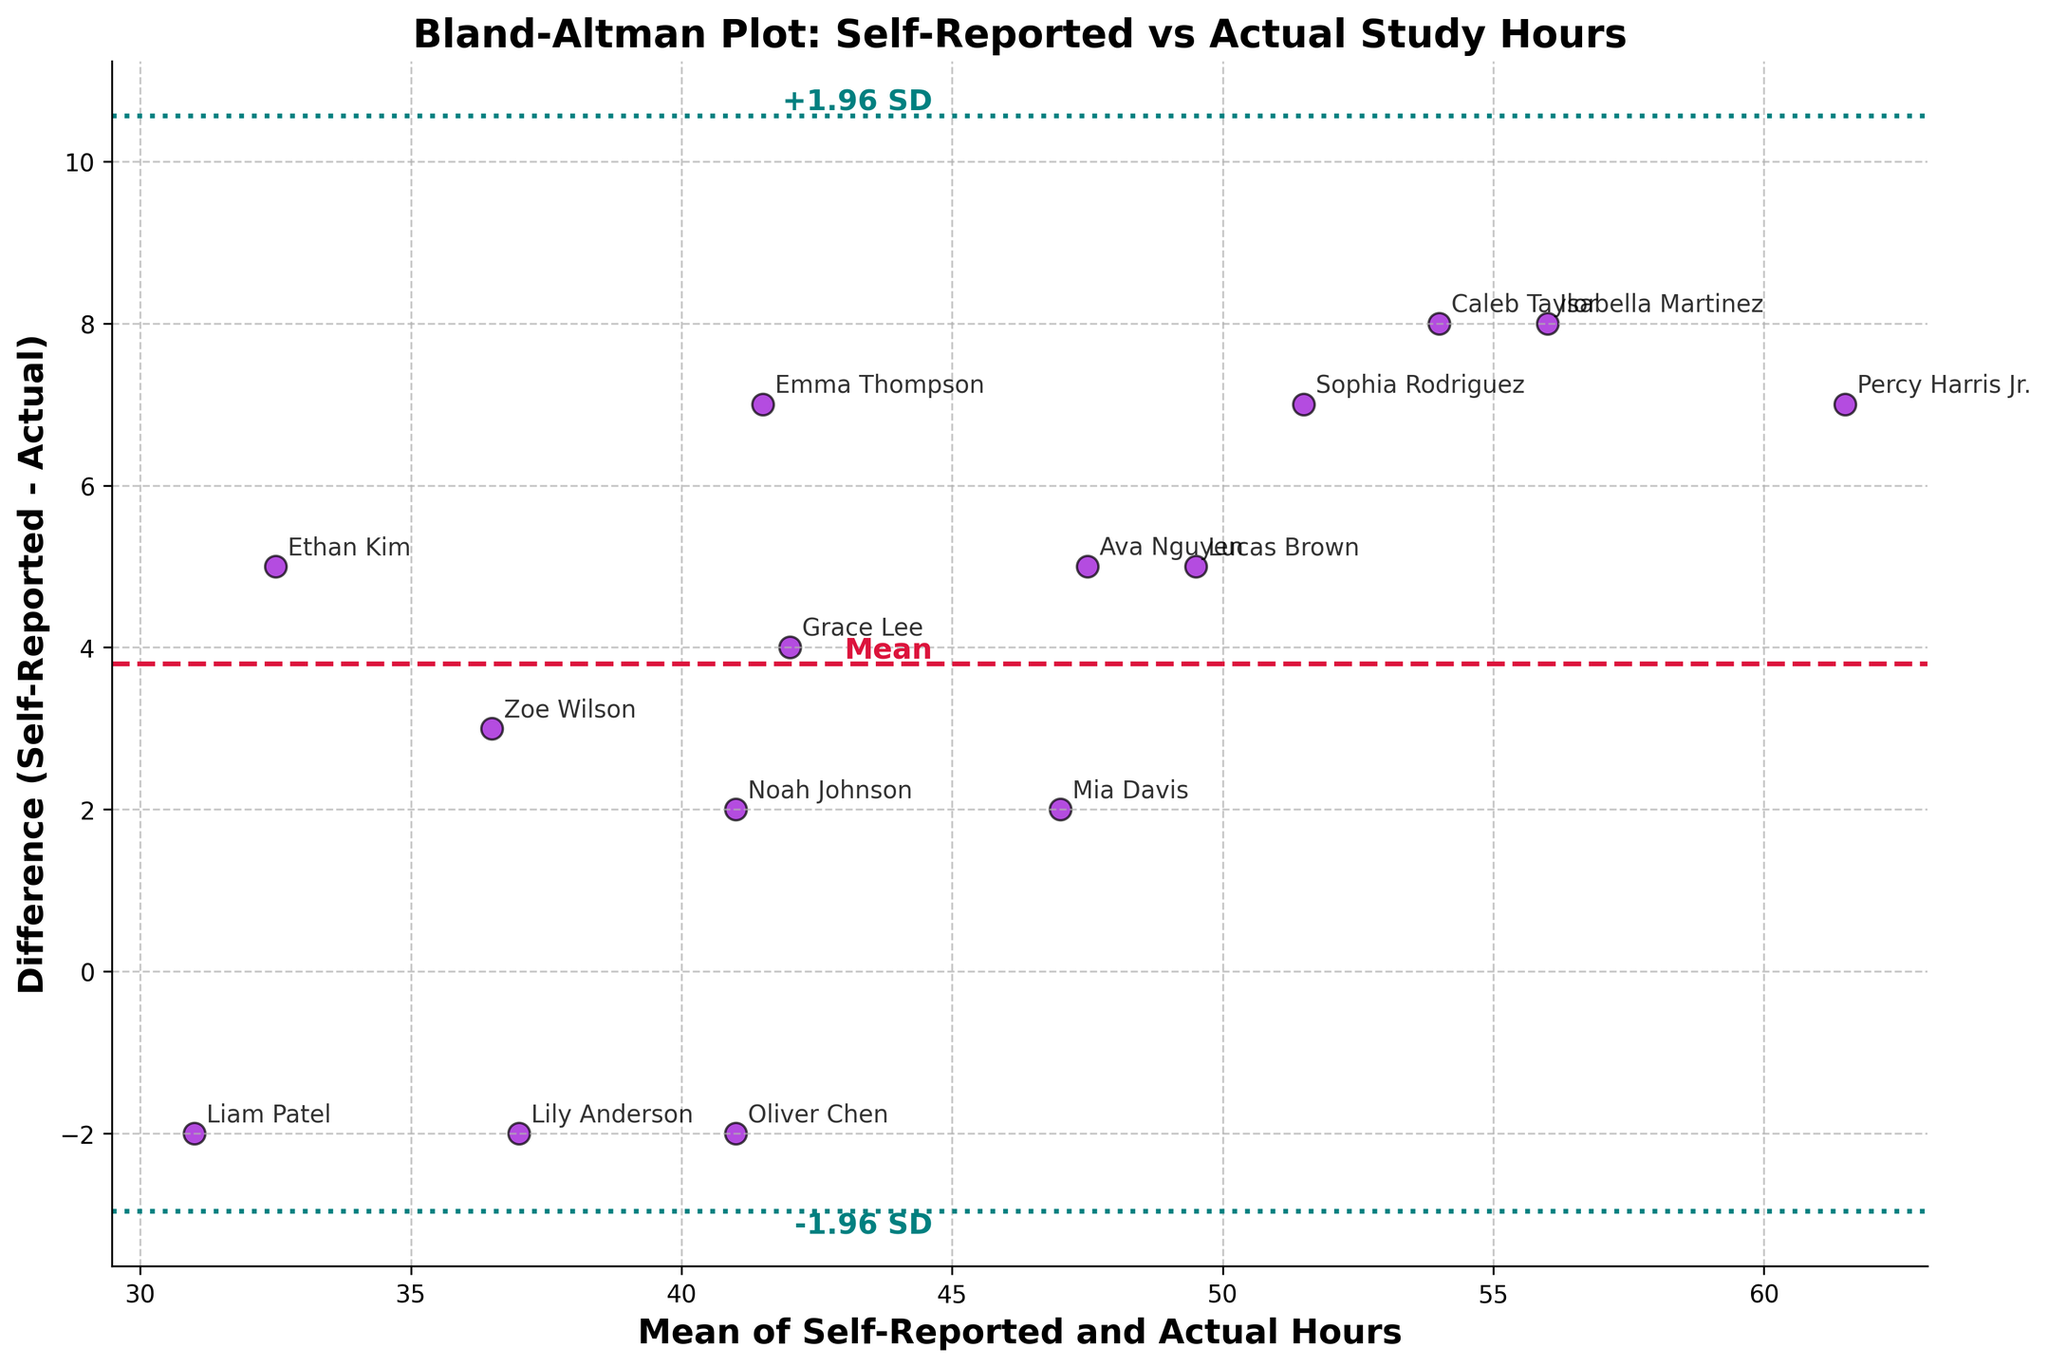What is the title of the plot? The title is prominently located at the top of the plot. It reads "Bland-Altman Plot: Self-Reported vs Actual Study Hours".
Answer: Bland-Altman Plot: Self-Reported vs Actual Study Hours What are the x and y-axes labels? The x-axis label is "Mean of Self-Reported and Actual Hours", and the y-axis label is "Difference (Self-Reported - Actual)". These labels describe what each axis represents in the plot.
Answer: Mean of Self-Reported and Actual Hours; Difference (Self-Reported - Actual) How many data points are plotted? By counting each individual scatter point on the plot, we see that there are a total of 15 data points. Each data point represents one student.
Answer: 15 What is the mean difference between self-reported and actual study hours? The horizontal dashed line in crimson represents the mean difference. According to the plot annotations, it is located near the center.
Answer: Approximately 4.07 What student has the highest average of self-reported and actual study hours? Each point represents a student and is annotated with their names. The highest average appears on the right side and belongs to "Percy Harris Jr." with a mean value calculated from the plot.
Answer: Percy Harris Jr Which student reported more study hours than they actually studied? Data points above the horizontal line at y=0 indicate students who reported more hours than they actually studied. From the plot, identify the names attached to these points.
Answer: Percy Harris Jr., Zoe Wilson, Ava Nguyen, Emma Thompson, Lucas Brown, Sophia Rodriguez, Caleb Taylor What are the upper and lower limits of agreement? The upper and lower limits of agreement are represented by the teal dotted lines and are labeled with "+1.96 SD" and "-1.96 SD" respectively.
Answer: Approximately 10.14 and -2.00 How many students have a difference in reported hours within the limits of agreement? Count the data points that fall within the upper and lower limits of agreement, marked by the teal dotted lines.
Answer: 13 Which student has the largest difference between self-reported and actual study hours? Look for the point with the greatest vertical distance from the x-axis, labeled with a student's name.
Answer: Percy Harris Jr Is there a general trend visible in the differences between self-reported and actual study hours? Visually inspect the scatter plot to determine if the differences tend to show any specific pattern, such as increasing or decreasing. The plot appears to show that students tend to over-report their study hours compared to their actual study hours.
Answer: Over-reporting trend 